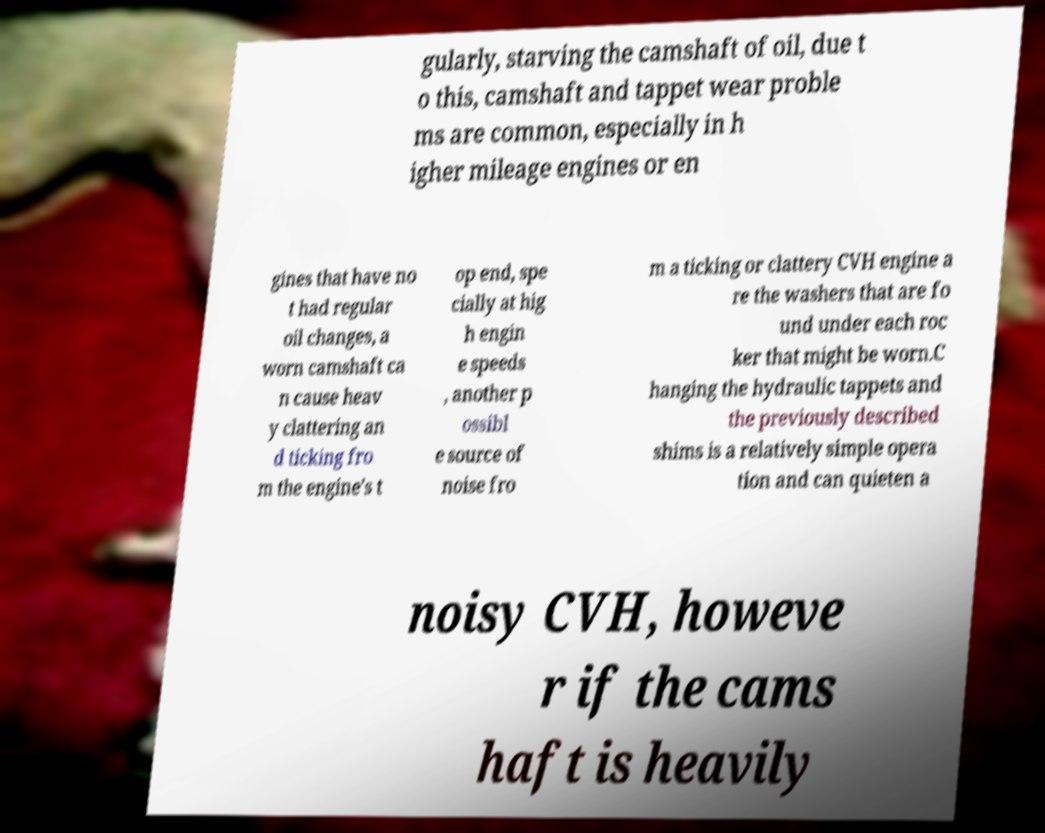Can you read and provide the text displayed in the image?This photo seems to have some interesting text. Can you extract and type it out for me? gularly, starving the camshaft of oil, due t o this, camshaft and tappet wear proble ms are common, especially in h igher mileage engines or en gines that have no t had regular oil changes, a worn camshaft ca n cause heav y clattering an d ticking fro m the engine's t op end, spe cially at hig h engin e speeds , another p ossibl e source of noise fro m a ticking or clattery CVH engine a re the washers that are fo und under each roc ker that might be worn.C hanging the hydraulic tappets and the previously described shims is a relatively simple opera tion and can quieten a noisy CVH, howeve r if the cams haft is heavily 